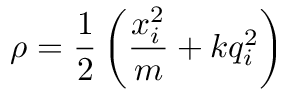<formula> <loc_0><loc_0><loc_500><loc_500>\rho = \frac { 1 } { 2 } \left ( \frac { x _ { i } ^ { 2 } } { m } + k q _ { i } ^ { 2 } \right )</formula> 